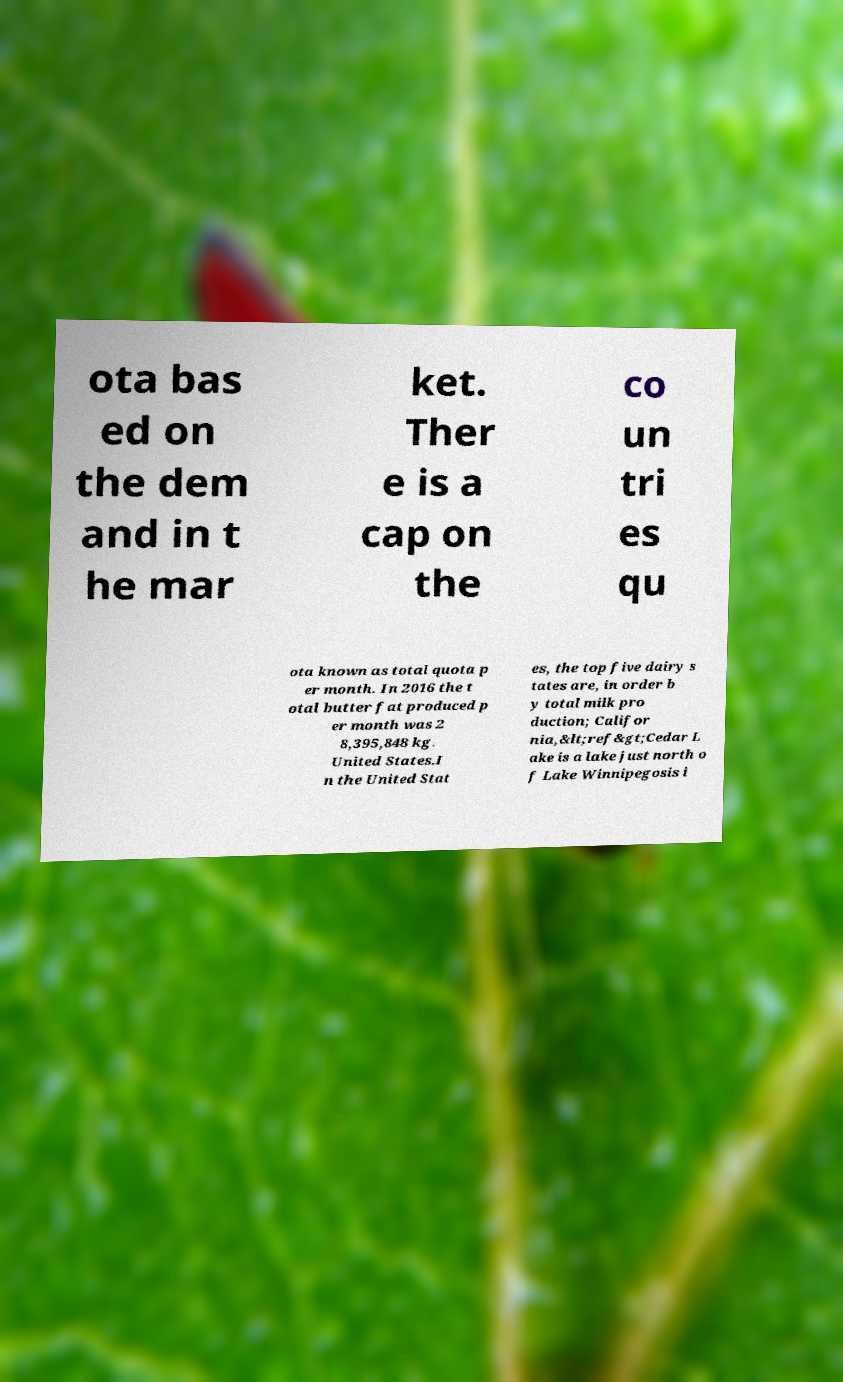Could you extract and type out the text from this image? ota bas ed on the dem and in t he mar ket. Ther e is a cap on the co un tri es qu ota known as total quota p er month. In 2016 the t otal butter fat produced p er month was 2 8,395,848 kg. United States.I n the United Stat es, the top five dairy s tates are, in order b y total milk pro duction; Califor nia,&lt;ref&gt;Cedar L ake is a lake just north o f Lake Winnipegosis i 